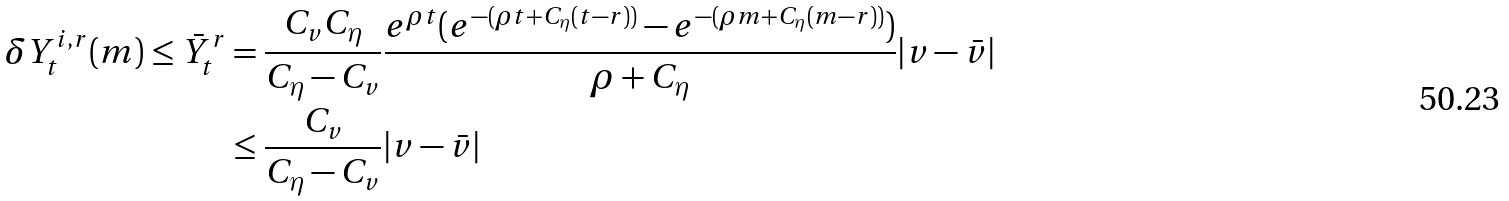<formula> <loc_0><loc_0><loc_500><loc_500>\delta Y _ { t } ^ { i , r } ( m ) \leq \bar { Y } _ { t } ^ { r } & = \frac { C _ { v } C _ { \eta } } { C _ { \eta } - C _ { v } } \frac { e ^ { \rho t } ( e ^ { - ( \rho t + C _ { \eta } ( t - r ) ) } - e ^ { - ( \rho m + C _ { \eta } ( m - r ) ) } ) } { \rho + C _ { \eta } } | v - \bar { v } | \\ & \leq \frac { C _ { v } } { C _ { \eta } - C _ { v } } | v - \bar { v } |</formula> 